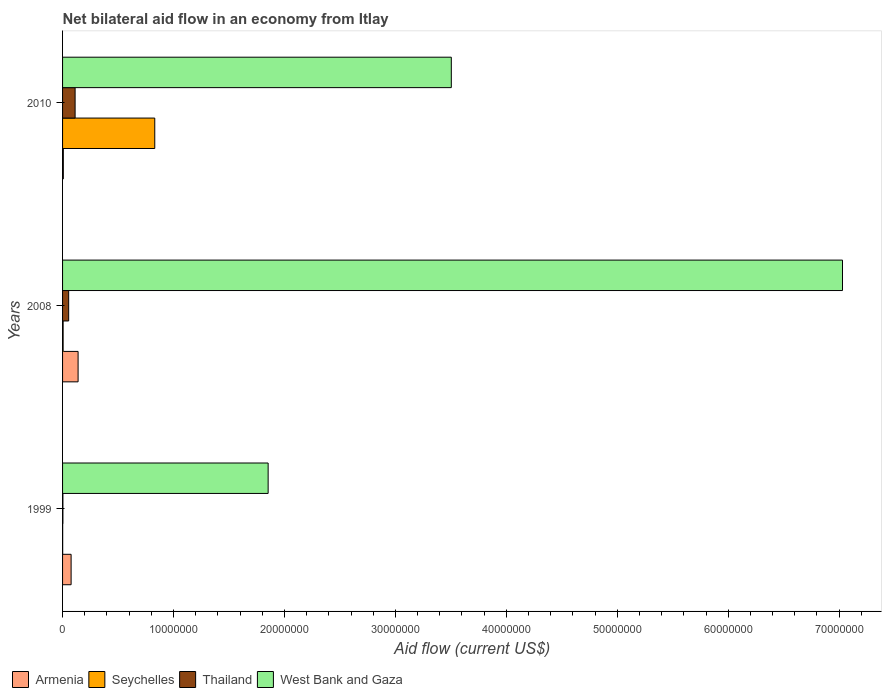How many different coloured bars are there?
Your answer should be very brief. 4. How many groups of bars are there?
Keep it short and to the point. 3. Are the number of bars per tick equal to the number of legend labels?
Keep it short and to the point. Yes. What is the net bilateral aid flow in Armenia in 2008?
Make the answer very short. 1.40e+06. Across all years, what is the maximum net bilateral aid flow in Seychelles?
Keep it short and to the point. 8.31e+06. In which year was the net bilateral aid flow in West Bank and Gaza maximum?
Provide a short and direct response. 2008. In which year was the net bilateral aid flow in Armenia minimum?
Your answer should be compact. 2010. What is the total net bilateral aid flow in Seychelles in the graph?
Make the answer very short. 8.37e+06. What is the difference between the net bilateral aid flow in Seychelles in 1999 and that in 2010?
Keep it short and to the point. -8.30e+06. What is the difference between the net bilateral aid flow in Armenia in 2010 and the net bilateral aid flow in Seychelles in 2008?
Your answer should be compact. 2.00e+04. What is the average net bilateral aid flow in West Bank and Gaza per year?
Your answer should be very brief. 4.13e+07. In the year 2008, what is the difference between the net bilateral aid flow in Seychelles and net bilateral aid flow in Armenia?
Your answer should be very brief. -1.35e+06. In how many years, is the net bilateral aid flow in Armenia greater than 46000000 US$?
Offer a very short reply. 0. What is the ratio of the net bilateral aid flow in Thailand in 1999 to that in 2010?
Ensure brevity in your answer.  0.03. What is the difference between the highest and the second highest net bilateral aid flow in Seychelles?
Ensure brevity in your answer.  8.26e+06. What is the difference between the highest and the lowest net bilateral aid flow in West Bank and Gaza?
Provide a succinct answer. 5.18e+07. In how many years, is the net bilateral aid flow in Thailand greater than the average net bilateral aid flow in Thailand taken over all years?
Provide a short and direct response. 1. Is the sum of the net bilateral aid flow in Armenia in 1999 and 2010 greater than the maximum net bilateral aid flow in Thailand across all years?
Make the answer very short. No. Is it the case that in every year, the sum of the net bilateral aid flow in Seychelles and net bilateral aid flow in Thailand is greater than the sum of net bilateral aid flow in Armenia and net bilateral aid flow in West Bank and Gaza?
Your response must be concise. No. What does the 3rd bar from the top in 1999 represents?
Your response must be concise. Seychelles. What does the 4th bar from the bottom in 2010 represents?
Keep it short and to the point. West Bank and Gaza. Is it the case that in every year, the sum of the net bilateral aid flow in Armenia and net bilateral aid flow in Thailand is greater than the net bilateral aid flow in Seychelles?
Offer a terse response. No. How many years are there in the graph?
Provide a short and direct response. 3. Does the graph contain any zero values?
Provide a succinct answer. No. Does the graph contain grids?
Provide a succinct answer. No. Where does the legend appear in the graph?
Provide a succinct answer. Bottom left. How many legend labels are there?
Provide a succinct answer. 4. What is the title of the graph?
Offer a terse response. Net bilateral aid flow in an economy from Itlay. What is the label or title of the X-axis?
Your answer should be very brief. Aid flow (current US$). What is the Aid flow (current US$) in Armenia in 1999?
Offer a terse response. 7.70e+05. What is the Aid flow (current US$) in Thailand in 1999?
Offer a terse response. 3.00e+04. What is the Aid flow (current US$) of West Bank and Gaza in 1999?
Your response must be concise. 1.85e+07. What is the Aid flow (current US$) of Armenia in 2008?
Make the answer very short. 1.40e+06. What is the Aid flow (current US$) of West Bank and Gaza in 2008?
Offer a terse response. 7.03e+07. What is the Aid flow (current US$) in Armenia in 2010?
Provide a short and direct response. 7.00e+04. What is the Aid flow (current US$) in Seychelles in 2010?
Provide a succinct answer. 8.31e+06. What is the Aid flow (current US$) of Thailand in 2010?
Ensure brevity in your answer.  1.13e+06. What is the Aid flow (current US$) of West Bank and Gaza in 2010?
Offer a terse response. 3.50e+07. Across all years, what is the maximum Aid flow (current US$) in Armenia?
Make the answer very short. 1.40e+06. Across all years, what is the maximum Aid flow (current US$) in Seychelles?
Your answer should be compact. 8.31e+06. Across all years, what is the maximum Aid flow (current US$) in Thailand?
Offer a terse response. 1.13e+06. Across all years, what is the maximum Aid flow (current US$) of West Bank and Gaza?
Your answer should be very brief. 7.03e+07. Across all years, what is the minimum Aid flow (current US$) of Seychelles?
Your answer should be very brief. 10000. Across all years, what is the minimum Aid flow (current US$) in Thailand?
Your answer should be compact. 3.00e+04. Across all years, what is the minimum Aid flow (current US$) in West Bank and Gaza?
Make the answer very short. 1.85e+07. What is the total Aid flow (current US$) in Armenia in the graph?
Give a very brief answer. 2.24e+06. What is the total Aid flow (current US$) in Seychelles in the graph?
Provide a succinct answer. 8.37e+06. What is the total Aid flow (current US$) in Thailand in the graph?
Offer a very short reply. 1.71e+06. What is the total Aid flow (current US$) of West Bank and Gaza in the graph?
Make the answer very short. 1.24e+08. What is the difference between the Aid flow (current US$) in Armenia in 1999 and that in 2008?
Provide a short and direct response. -6.30e+05. What is the difference between the Aid flow (current US$) in Seychelles in 1999 and that in 2008?
Your answer should be very brief. -4.00e+04. What is the difference between the Aid flow (current US$) in Thailand in 1999 and that in 2008?
Keep it short and to the point. -5.20e+05. What is the difference between the Aid flow (current US$) of West Bank and Gaza in 1999 and that in 2008?
Keep it short and to the point. -5.18e+07. What is the difference between the Aid flow (current US$) of Armenia in 1999 and that in 2010?
Your answer should be compact. 7.00e+05. What is the difference between the Aid flow (current US$) of Seychelles in 1999 and that in 2010?
Make the answer very short. -8.30e+06. What is the difference between the Aid flow (current US$) in Thailand in 1999 and that in 2010?
Ensure brevity in your answer.  -1.10e+06. What is the difference between the Aid flow (current US$) of West Bank and Gaza in 1999 and that in 2010?
Offer a terse response. -1.65e+07. What is the difference between the Aid flow (current US$) of Armenia in 2008 and that in 2010?
Offer a very short reply. 1.33e+06. What is the difference between the Aid flow (current US$) in Seychelles in 2008 and that in 2010?
Your answer should be compact. -8.26e+06. What is the difference between the Aid flow (current US$) of Thailand in 2008 and that in 2010?
Offer a very short reply. -5.80e+05. What is the difference between the Aid flow (current US$) of West Bank and Gaza in 2008 and that in 2010?
Keep it short and to the point. 3.53e+07. What is the difference between the Aid flow (current US$) of Armenia in 1999 and the Aid flow (current US$) of Seychelles in 2008?
Make the answer very short. 7.20e+05. What is the difference between the Aid flow (current US$) in Armenia in 1999 and the Aid flow (current US$) in Thailand in 2008?
Offer a very short reply. 2.20e+05. What is the difference between the Aid flow (current US$) of Armenia in 1999 and the Aid flow (current US$) of West Bank and Gaza in 2008?
Make the answer very short. -6.95e+07. What is the difference between the Aid flow (current US$) in Seychelles in 1999 and the Aid flow (current US$) in Thailand in 2008?
Give a very brief answer. -5.40e+05. What is the difference between the Aid flow (current US$) of Seychelles in 1999 and the Aid flow (current US$) of West Bank and Gaza in 2008?
Give a very brief answer. -7.03e+07. What is the difference between the Aid flow (current US$) of Thailand in 1999 and the Aid flow (current US$) of West Bank and Gaza in 2008?
Make the answer very short. -7.03e+07. What is the difference between the Aid flow (current US$) in Armenia in 1999 and the Aid flow (current US$) in Seychelles in 2010?
Keep it short and to the point. -7.54e+06. What is the difference between the Aid flow (current US$) of Armenia in 1999 and the Aid flow (current US$) of Thailand in 2010?
Your response must be concise. -3.60e+05. What is the difference between the Aid flow (current US$) of Armenia in 1999 and the Aid flow (current US$) of West Bank and Gaza in 2010?
Your answer should be compact. -3.43e+07. What is the difference between the Aid flow (current US$) of Seychelles in 1999 and the Aid flow (current US$) of Thailand in 2010?
Your answer should be very brief. -1.12e+06. What is the difference between the Aid flow (current US$) in Seychelles in 1999 and the Aid flow (current US$) in West Bank and Gaza in 2010?
Your response must be concise. -3.50e+07. What is the difference between the Aid flow (current US$) in Thailand in 1999 and the Aid flow (current US$) in West Bank and Gaza in 2010?
Your answer should be very brief. -3.50e+07. What is the difference between the Aid flow (current US$) in Armenia in 2008 and the Aid flow (current US$) in Seychelles in 2010?
Offer a very short reply. -6.91e+06. What is the difference between the Aid flow (current US$) of Armenia in 2008 and the Aid flow (current US$) of Thailand in 2010?
Ensure brevity in your answer.  2.70e+05. What is the difference between the Aid flow (current US$) of Armenia in 2008 and the Aid flow (current US$) of West Bank and Gaza in 2010?
Provide a short and direct response. -3.36e+07. What is the difference between the Aid flow (current US$) of Seychelles in 2008 and the Aid flow (current US$) of Thailand in 2010?
Your answer should be very brief. -1.08e+06. What is the difference between the Aid flow (current US$) of Seychelles in 2008 and the Aid flow (current US$) of West Bank and Gaza in 2010?
Your response must be concise. -3.50e+07. What is the difference between the Aid flow (current US$) in Thailand in 2008 and the Aid flow (current US$) in West Bank and Gaza in 2010?
Your answer should be very brief. -3.45e+07. What is the average Aid flow (current US$) of Armenia per year?
Provide a succinct answer. 7.47e+05. What is the average Aid flow (current US$) of Seychelles per year?
Give a very brief answer. 2.79e+06. What is the average Aid flow (current US$) of Thailand per year?
Your response must be concise. 5.70e+05. What is the average Aid flow (current US$) of West Bank and Gaza per year?
Your response must be concise. 4.13e+07. In the year 1999, what is the difference between the Aid flow (current US$) in Armenia and Aid flow (current US$) in Seychelles?
Your answer should be compact. 7.60e+05. In the year 1999, what is the difference between the Aid flow (current US$) of Armenia and Aid flow (current US$) of Thailand?
Give a very brief answer. 7.40e+05. In the year 1999, what is the difference between the Aid flow (current US$) in Armenia and Aid flow (current US$) in West Bank and Gaza?
Provide a short and direct response. -1.78e+07. In the year 1999, what is the difference between the Aid flow (current US$) of Seychelles and Aid flow (current US$) of Thailand?
Ensure brevity in your answer.  -2.00e+04. In the year 1999, what is the difference between the Aid flow (current US$) in Seychelles and Aid flow (current US$) in West Bank and Gaza?
Offer a very short reply. -1.85e+07. In the year 1999, what is the difference between the Aid flow (current US$) in Thailand and Aid flow (current US$) in West Bank and Gaza?
Give a very brief answer. -1.85e+07. In the year 2008, what is the difference between the Aid flow (current US$) of Armenia and Aid flow (current US$) of Seychelles?
Keep it short and to the point. 1.35e+06. In the year 2008, what is the difference between the Aid flow (current US$) of Armenia and Aid flow (current US$) of Thailand?
Provide a succinct answer. 8.50e+05. In the year 2008, what is the difference between the Aid flow (current US$) of Armenia and Aid flow (current US$) of West Bank and Gaza?
Provide a short and direct response. -6.89e+07. In the year 2008, what is the difference between the Aid flow (current US$) of Seychelles and Aid flow (current US$) of Thailand?
Provide a short and direct response. -5.00e+05. In the year 2008, what is the difference between the Aid flow (current US$) in Seychelles and Aid flow (current US$) in West Bank and Gaza?
Provide a succinct answer. -7.02e+07. In the year 2008, what is the difference between the Aid flow (current US$) of Thailand and Aid flow (current US$) of West Bank and Gaza?
Give a very brief answer. -6.98e+07. In the year 2010, what is the difference between the Aid flow (current US$) in Armenia and Aid flow (current US$) in Seychelles?
Offer a very short reply. -8.24e+06. In the year 2010, what is the difference between the Aid flow (current US$) of Armenia and Aid flow (current US$) of Thailand?
Offer a terse response. -1.06e+06. In the year 2010, what is the difference between the Aid flow (current US$) in Armenia and Aid flow (current US$) in West Bank and Gaza?
Offer a terse response. -3.50e+07. In the year 2010, what is the difference between the Aid flow (current US$) in Seychelles and Aid flow (current US$) in Thailand?
Your answer should be compact. 7.18e+06. In the year 2010, what is the difference between the Aid flow (current US$) in Seychelles and Aid flow (current US$) in West Bank and Gaza?
Ensure brevity in your answer.  -2.67e+07. In the year 2010, what is the difference between the Aid flow (current US$) of Thailand and Aid flow (current US$) of West Bank and Gaza?
Your response must be concise. -3.39e+07. What is the ratio of the Aid flow (current US$) of Armenia in 1999 to that in 2008?
Your response must be concise. 0.55. What is the ratio of the Aid flow (current US$) of Thailand in 1999 to that in 2008?
Ensure brevity in your answer.  0.05. What is the ratio of the Aid flow (current US$) of West Bank and Gaza in 1999 to that in 2008?
Keep it short and to the point. 0.26. What is the ratio of the Aid flow (current US$) of Armenia in 1999 to that in 2010?
Your answer should be very brief. 11. What is the ratio of the Aid flow (current US$) in Seychelles in 1999 to that in 2010?
Your answer should be compact. 0. What is the ratio of the Aid flow (current US$) of Thailand in 1999 to that in 2010?
Your answer should be very brief. 0.03. What is the ratio of the Aid flow (current US$) in West Bank and Gaza in 1999 to that in 2010?
Your answer should be compact. 0.53. What is the ratio of the Aid flow (current US$) of Seychelles in 2008 to that in 2010?
Keep it short and to the point. 0.01. What is the ratio of the Aid flow (current US$) in Thailand in 2008 to that in 2010?
Your answer should be very brief. 0.49. What is the ratio of the Aid flow (current US$) in West Bank and Gaza in 2008 to that in 2010?
Provide a short and direct response. 2.01. What is the difference between the highest and the second highest Aid flow (current US$) in Armenia?
Your answer should be very brief. 6.30e+05. What is the difference between the highest and the second highest Aid flow (current US$) of Seychelles?
Provide a short and direct response. 8.26e+06. What is the difference between the highest and the second highest Aid flow (current US$) in Thailand?
Your answer should be very brief. 5.80e+05. What is the difference between the highest and the second highest Aid flow (current US$) of West Bank and Gaza?
Offer a terse response. 3.53e+07. What is the difference between the highest and the lowest Aid flow (current US$) in Armenia?
Keep it short and to the point. 1.33e+06. What is the difference between the highest and the lowest Aid flow (current US$) in Seychelles?
Your answer should be compact. 8.30e+06. What is the difference between the highest and the lowest Aid flow (current US$) of Thailand?
Provide a succinct answer. 1.10e+06. What is the difference between the highest and the lowest Aid flow (current US$) in West Bank and Gaza?
Offer a terse response. 5.18e+07. 